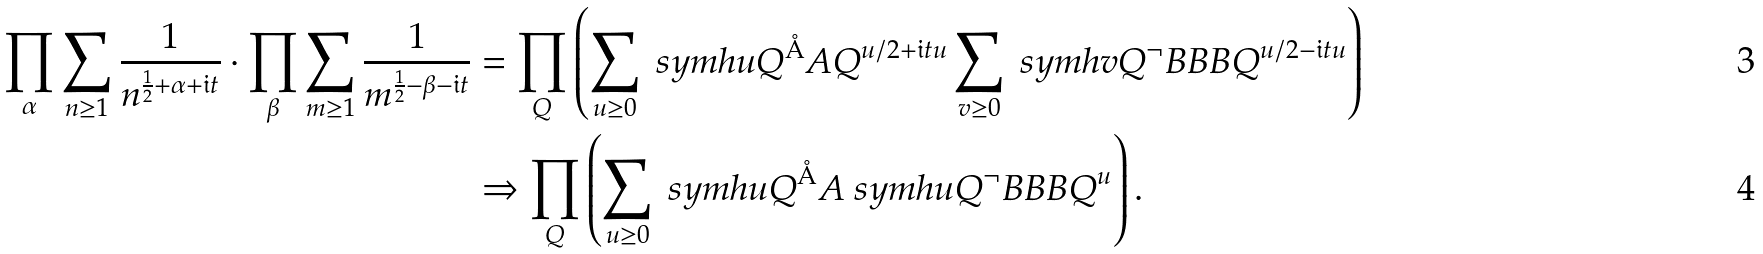Convert formula to latex. <formula><loc_0><loc_0><loc_500><loc_500>\prod _ { \alpha } \sum _ { n \geq 1 } \frac { 1 } { n ^ { \frac { 1 } { 2 } + \alpha + \mathfrak { i } t } } \cdot \prod _ { \beta } \sum _ { m \geq 1 } \frac { 1 } { m ^ { \frac { 1 } { 2 } - \beta - \mathfrak { i } t } } & = \prod _ { Q } \left ( \sum _ { u \geq 0 } \ s y m h { u } { Q ^ { \AA } A } Q ^ { u / 2 + \mathfrak { i } t u } \sum _ { v \geq 0 } \ s y m h { v } { Q ^ { \neg } B B B } Q ^ { u / 2 - \mathfrak { i } t u } \right ) \\ & \Rightarrow \prod _ { Q } \left ( \sum _ { u \geq 0 } \ s y m h { u } { Q ^ { \AA } A } \ s y m h { u } { Q ^ { \neg } B B B } Q ^ { u } \right ) .</formula> 